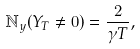<formula> <loc_0><loc_0><loc_500><loc_500>\mathbb { N } _ { y } ( Y _ { T } \neq 0 ) = \frac { 2 } { \gamma T } ,</formula> 